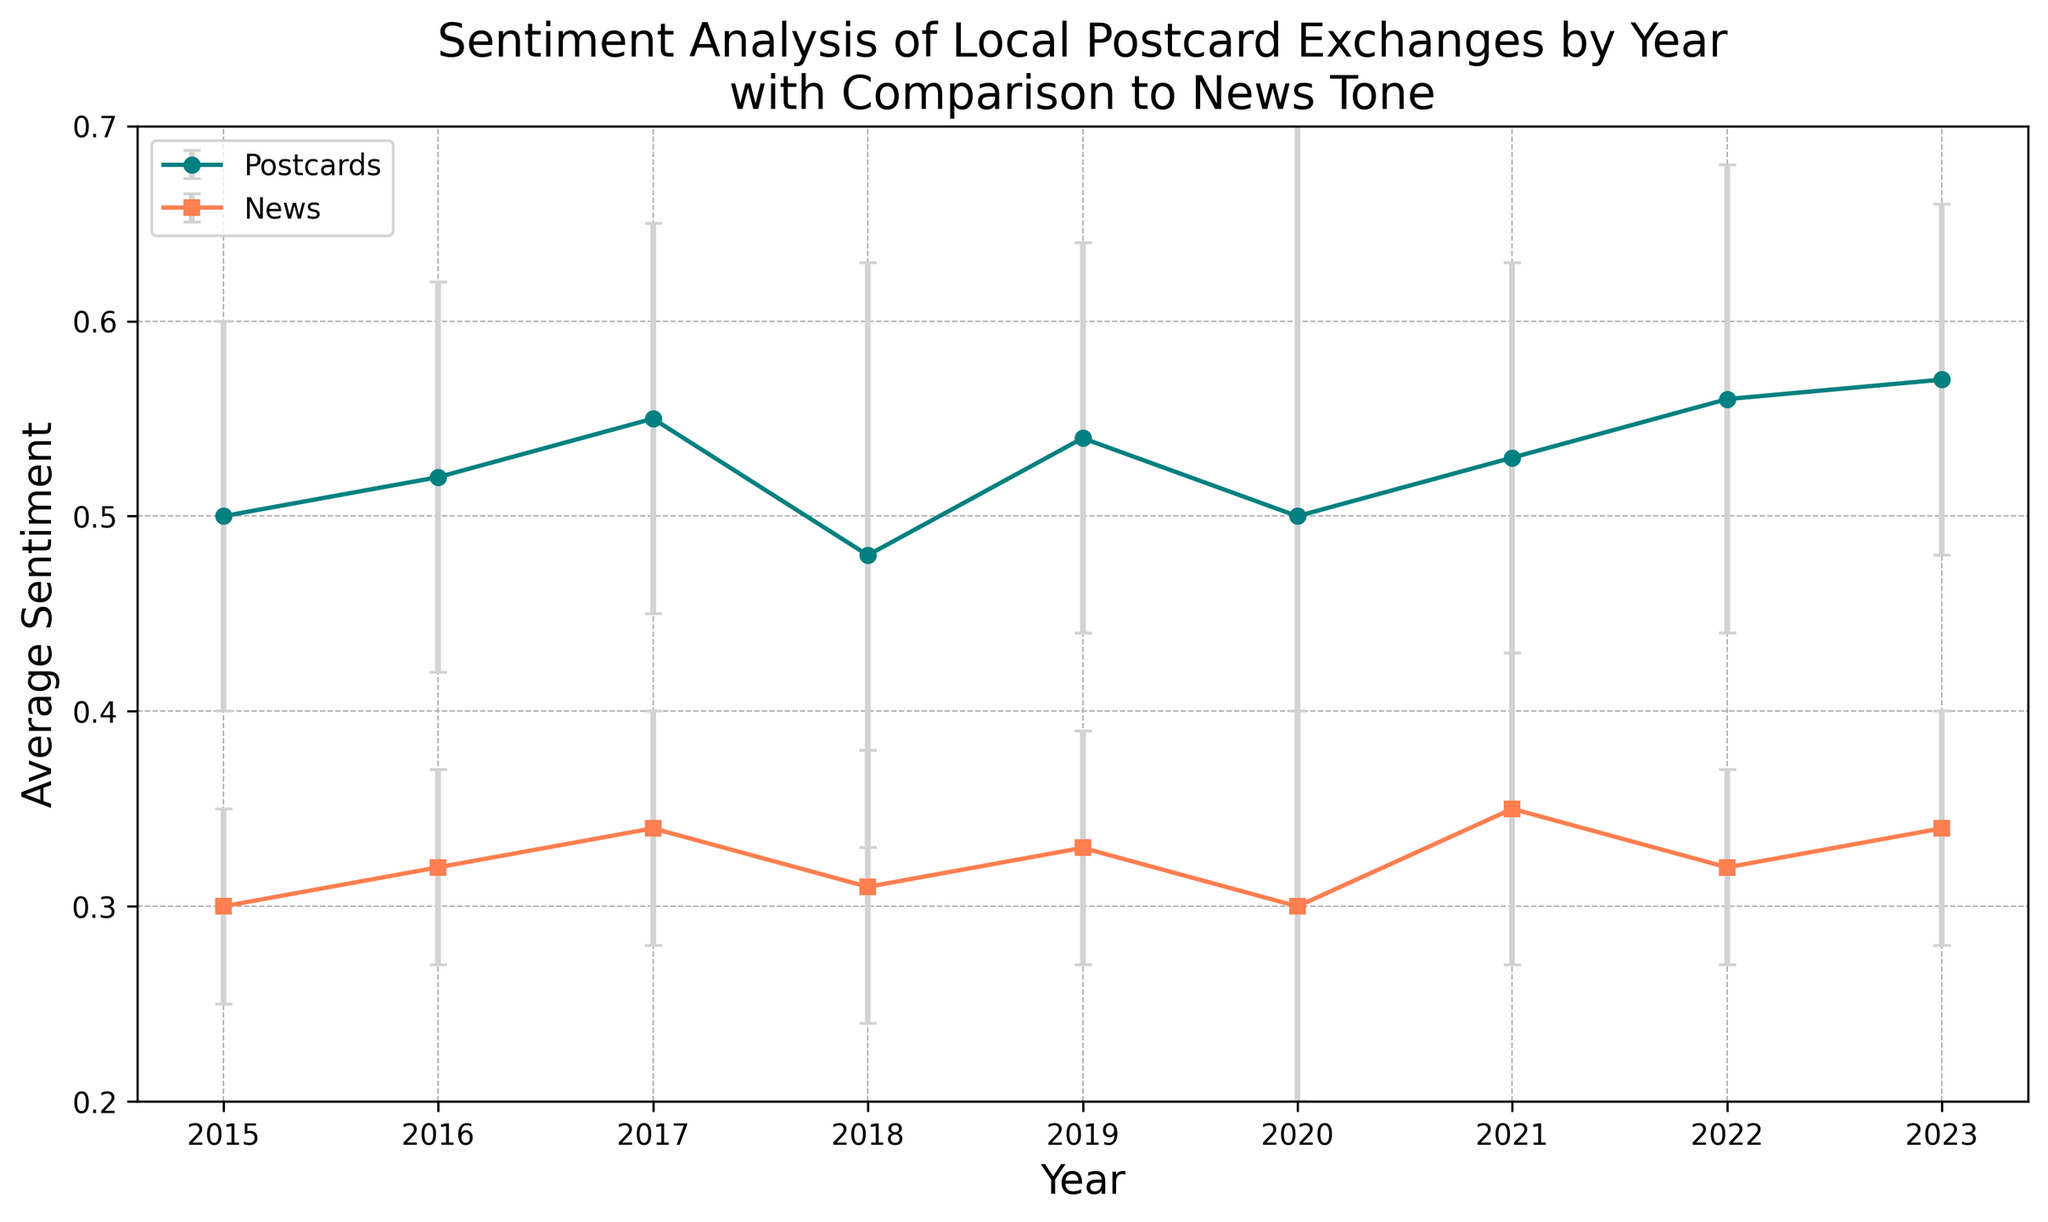What year had the highest average sentiment for postcard exchanges? By looking at the plot, the highest point on the teal line (postcards) is in 2023. This can be identified by observing the y-axis values for each year.
Answer: 2023 Does any year show an average sentiment for news higher than the average sentiment for postcards? By comparing the coral line (news) and the teal line (postcards) visually, it can be noted that at no point does the coral line exceed the teal line for any year on the y-axis values.
Answer: No In which year was the error margin for postcard sentiment the highest? The error bars visually represent the error margins. The teal error bar with the largest vertical length is in 2020.
Answer: 2020 What is the difference in average sentiment between postcards and news in 2017? Locate the average sentiment values for both postcards (0.55) and news (0.34) in 2017. Subtract the news sentiment from the postcard sentiment: 0.55 - 0.34 = 0.21.
Answer: 0.21 What is the average sentiment for postcards over the first three years (2015-2017)? Sum the average sentiment values for postcards in 2015, 2016, and 2017 (0.5 + 0.52 + 0.55) and divide by 3 to get the average: (0.5 + 0.52 + 0.55) / 3 = 1.57 / 3 = 0.523.
Answer: 0.523 How does the sentiment trend for postcards compare to the sentiment trend for news from 2020 to 2023? Observe the two lines (teal for postcards and coral for news) from 2020 to 2023. The postcard sentiment increases from 0.50 to 0.57, while the news sentiment also increases from 0.30 to 0.34. Both show an increasing trend.
Answer: Both increasing Which year has the smallest difference between average sentiment for postcards and average sentiment for news? Calculate and compare the differences for each year: 
2015: 0.2, 2016: 0.2, 2017: 0.21, 2018: 0.17, 2019: 0.21, 2020: 0.20, 2021: 0.18, 2022: 0.24, 2023: 0.23. The smallest difference is in 2018.
Answer: 2018 